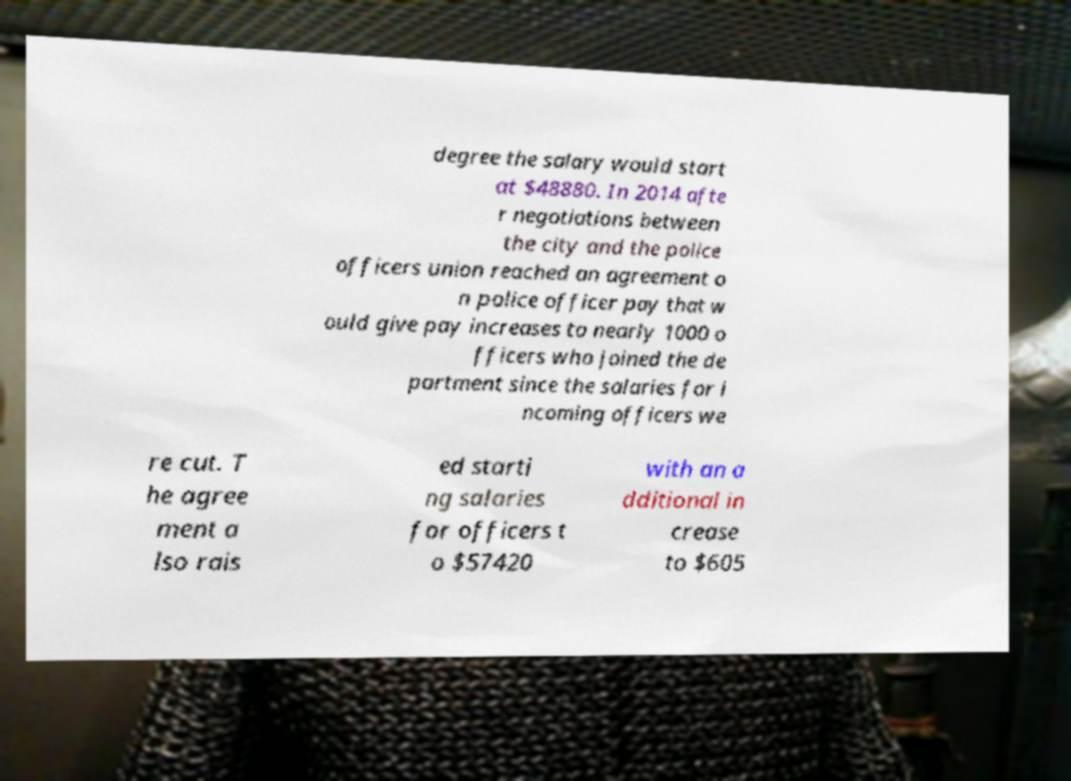Can you read and provide the text displayed in the image?This photo seems to have some interesting text. Can you extract and type it out for me? degree the salary would start at $48880. In 2014 afte r negotiations between the city and the police officers union reached an agreement o n police officer pay that w ould give pay increases to nearly 1000 o fficers who joined the de partment since the salaries for i ncoming officers we re cut. T he agree ment a lso rais ed starti ng salaries for officers t o $57420 with an a dditional in crease to $605 